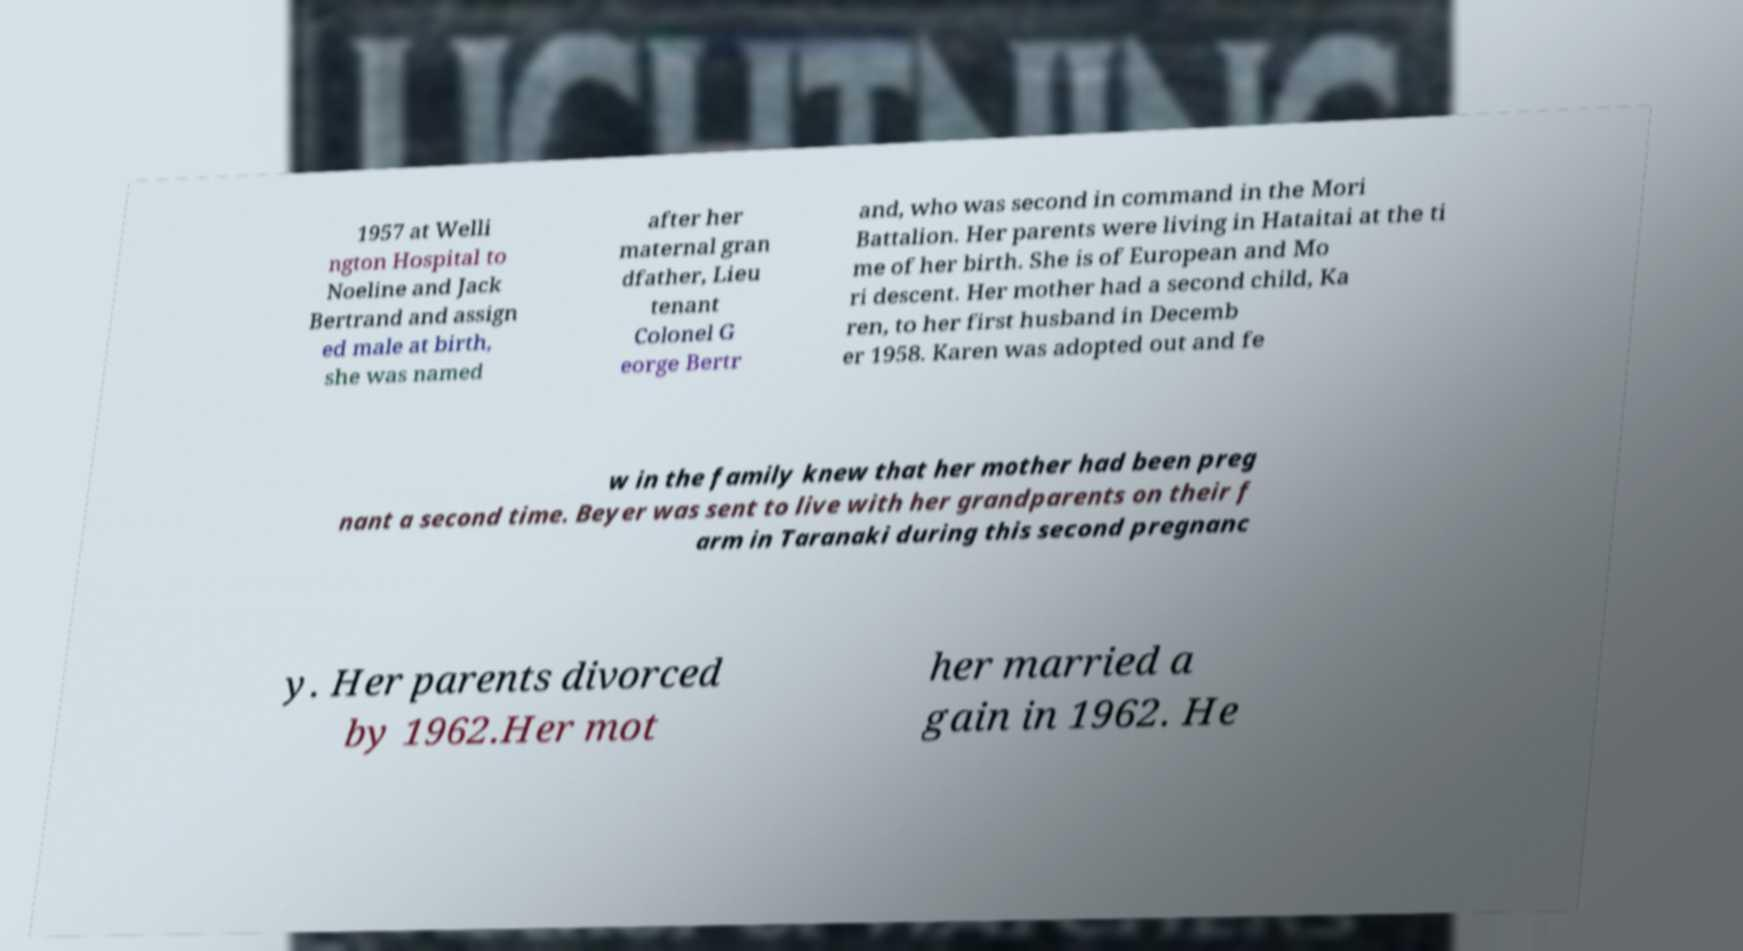Please identify and transcribe the text found in this image. 1957 at Welli ngton Hospital to Noeline and Jack Bertrand and assign ed male at birth, she was named after her maternal gran dfather, Lieu tenant Colonel G eorge Bertr and, who was second in command in the Mori Battalion. Her parents were living in Hataitai at the ti me of her birth. She is of European and Mo ri descent. Her mother had a second child, Ka ren, to her first husband in Decemb er 1958. Karen was adopted out and fe w in the family knew that her mother had been preg nant a second time. Beyer was sent to live with her grandparents on their f arm in Taranaki during this second pregnanc y. Her parents divorced by 1962.Her mot her married a gain in 1962. He 